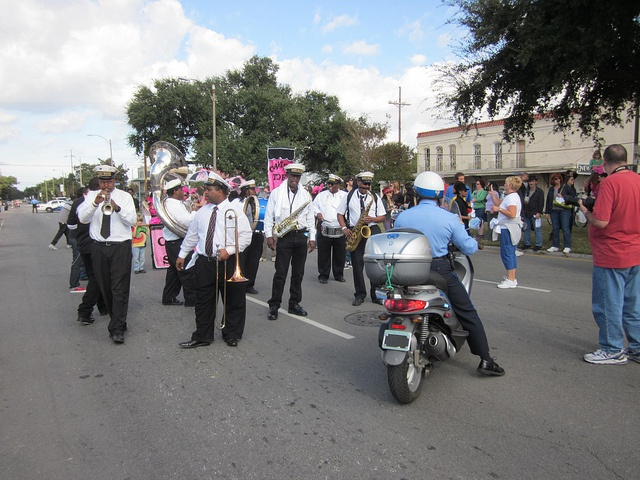Describe the objects in this image and their specific colors. I can see people in white, brown, gray, and blue tones, people in white, black, lavender, and gray tones, motorcycle in white, black, gray, darkgray, and maroon tones, people in white, black, lightgray, gray, and darkgray tones, and people in white, black, lightblue, and darkgray tones in this image. 